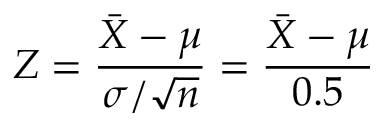Convert formula to latex. <formula><loc_0><loc_0><loc_500><loc_500>Z = { \frac { { \bar { X } } - \mu } { \sigma / { \sqrt { n } } } } = { \frac { { \bar { X } } - \mu } { 0 . 5 } }</formula> 